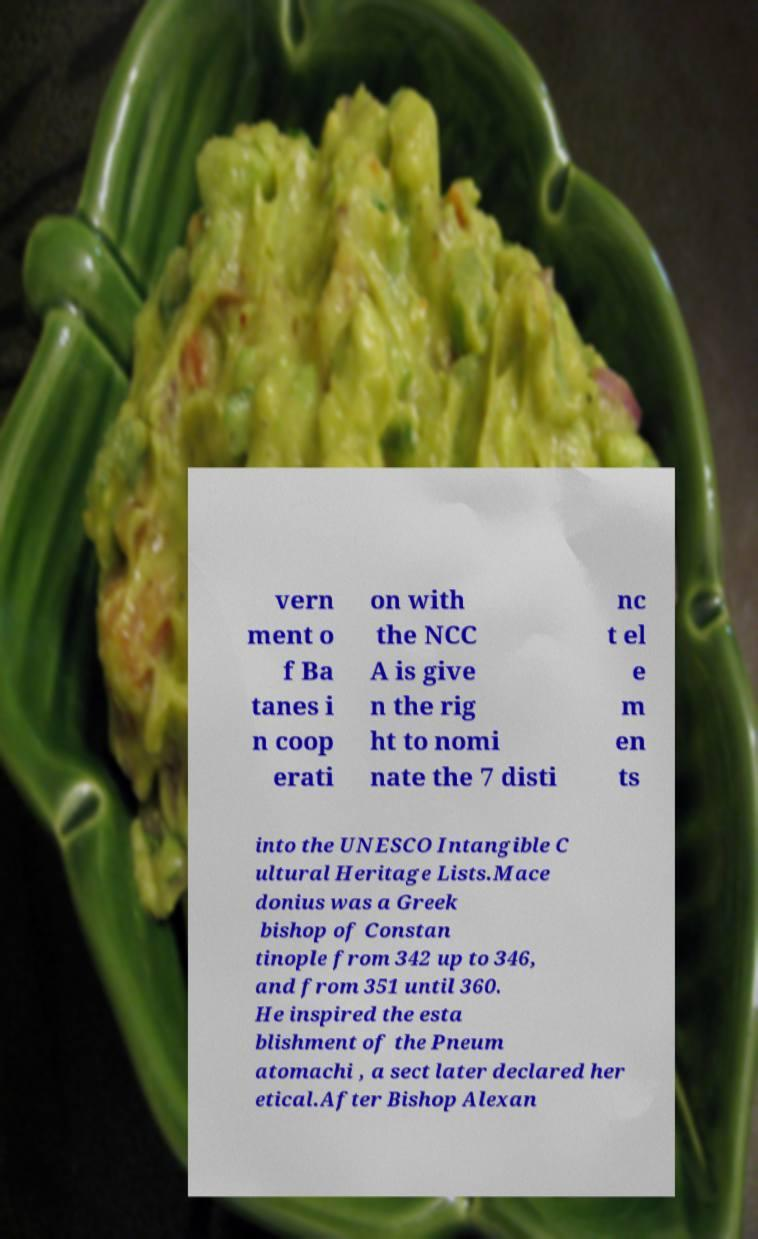Please identify and transcribe the text found in this image. vern ment o f Ba tanes i n coop erati on with the NCC A is give n the rig ht to nomi nate the 7 disti nc t el e m en ts into the UNESCO Intangible C ultural Heritage Lists.Mace donius was a Greek bishop of Constan tinople from 342 up to 346, and from 351 until 360. He inspired the esta blishment of the Pneum atomachi , a sect later declared her etical.After Bishop Alexan 